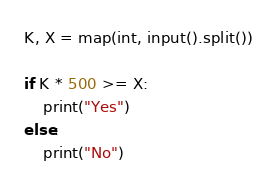<code> <loc_0><loc_0><loc_500><loc_500><_Python_>K, X = map(int, input().split())

if K * 500 >= X:
    print("Yes")
else:
    print("No")</code> 